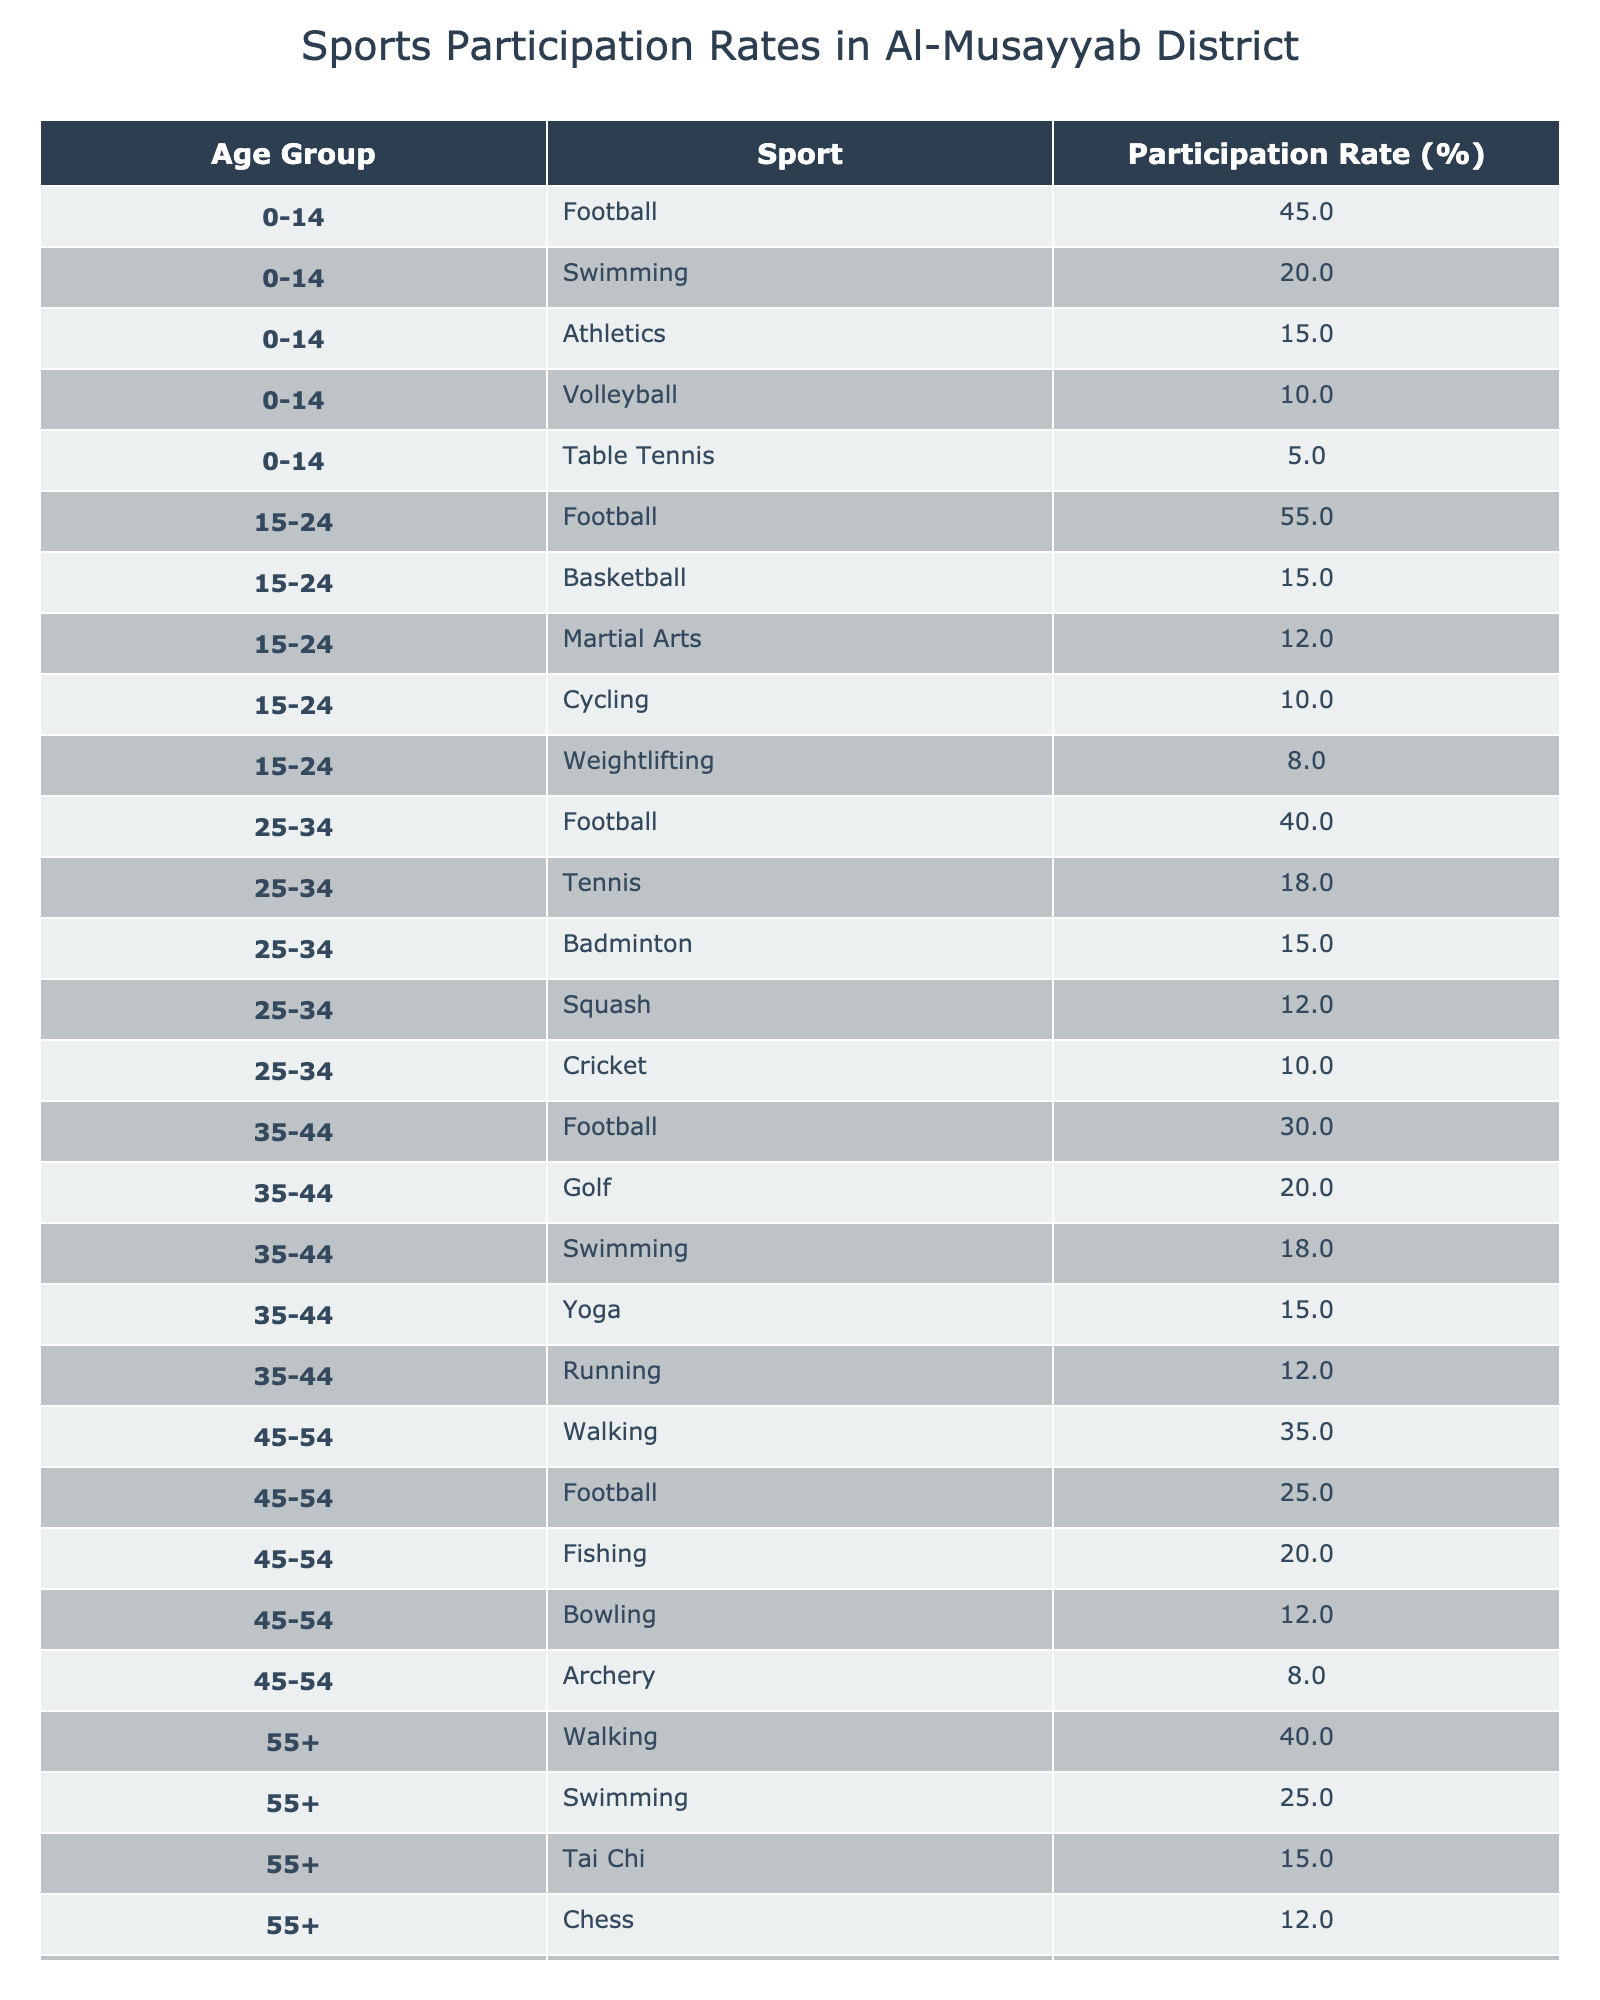What is the participation rate for Football in the age group 15-24? According to the table, the participation rate for Football in the age group 15-24 is listed as 55%.
Answer: 55% Which sport has the highest participation rate in the age group 0-14? In the age group 0-14, the sport with the highest participation rate is Football at 45%.
Answer: Football How many sports have a participation rate above 20% in the age group 35-44? In the age group 35-44, Football (30%), Golf (20%), and Swimming (18%) have rates close to or above 20%. Therefore, only Football meets that requirement.
Answer: 1 What is the average participation rate for Swimming across all age groups? The participation rates for Swimming in each age group are: 20% (0-14), 0% (15-24), 18% (35-44), and 25% (55+). So, the average is (20 + 0 + 18 + 25) / 4 = 15.75%.
Answer: 15.75% Which sport has the lowest participation rate in the age group 0-14? In the age group 0-14, Table Tennis has the lowest participation rate at 5%.
Answer: Table Tennis Is the participation rate for Football higher in the age group 15-24 than in 25-34? Yes, the participation rate for Football in the age group 15-24 is 55%, while in the age group 25-34, it is 40%. Thus, it is higher in the younger group.
Answer: Yes What are the participation rates for Walking in both age groups where it appears? Walking appears in the age groups 45-54 (35%) and 55+ (40%). Therefore, the rates are 35% and 40%, respectively.
Answer: 35% and 40% Which age group has the highest average participation rate across all sports? To find the average, calculate the total participation rates for each age group: 0-14: 45 + 20 + 15 + 10 + 5 = 95%, 15-24: 55 + 15 + 12 + 10 + 8 = 100%, 25-34: 40 + 18 + 15 + 12 + 10 = 95%, 35-44: 30 + 20 + 18 + 15 + 12 = 95%, 45-54: 35 + 25 + 20 + 12 + 8 = 100%, 55+: 40 + 25 + 15 + 12 + 8 = 100%. The highest average participation rates are in the age groups 15-24 and 45-54 and 55+.
Answer: 100% How do the participation rates for Football in the age groups 25-34 and 45-54 compare? Football has a participation rate of 40% in the age group 25-34 and 25% in the age group 45-54. Therefore, the rate is higher in the younger age group.
Answer: Higher in 25-34 What percentage of 55+ participants are involved in Chess? The participation rate for Chess in the 55+ age group is 12%.
Answer: 12% Do more people participate in Volleyball compared to Basketball in the age group 15-24? In the age group 15-24, Volleyball participation is 0% (not listed), while Basketball is at 15%. Therefore, more people participate in Basketball.
Answer: No 